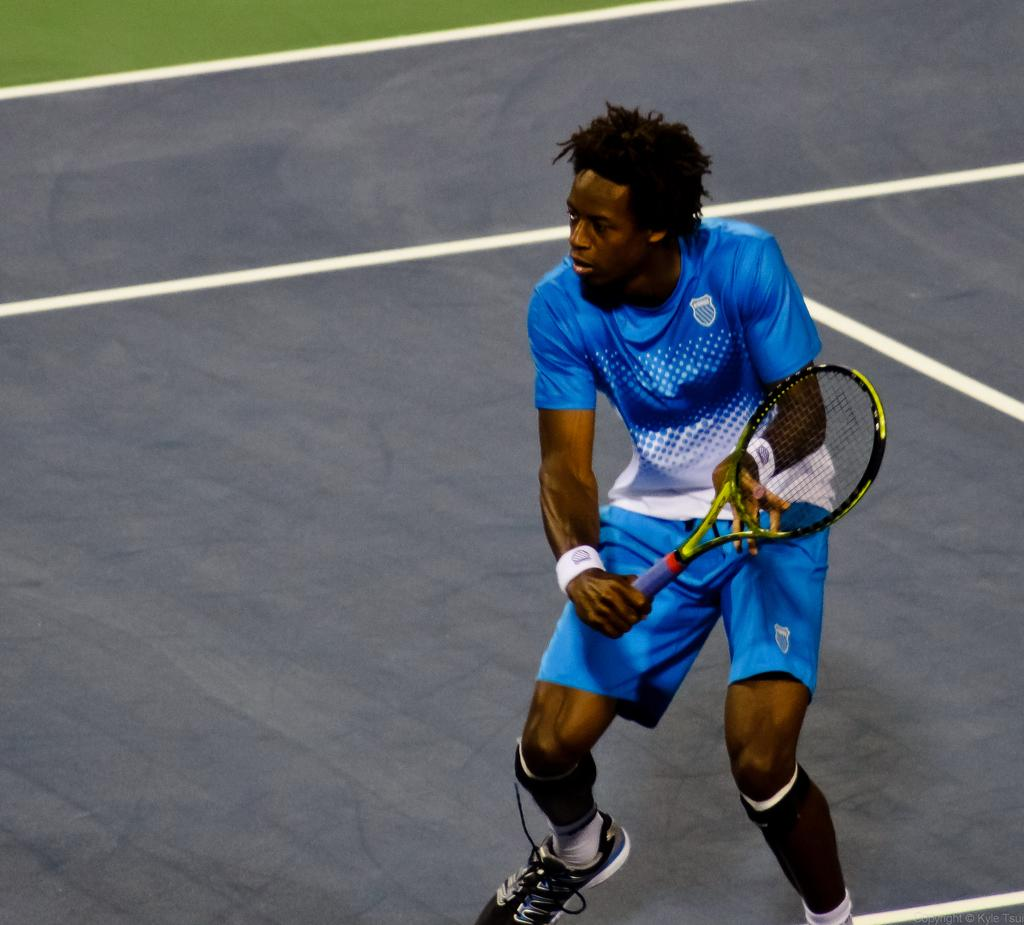What is the main subject of the image? The main subject of the image is a man. What is the man holding in the image? The man is holding a racket with his hands. What type of magic is the man performing with the racket in the image? There is no magic or any indication of magic being performed in the image; the man is simply holding a racket. 